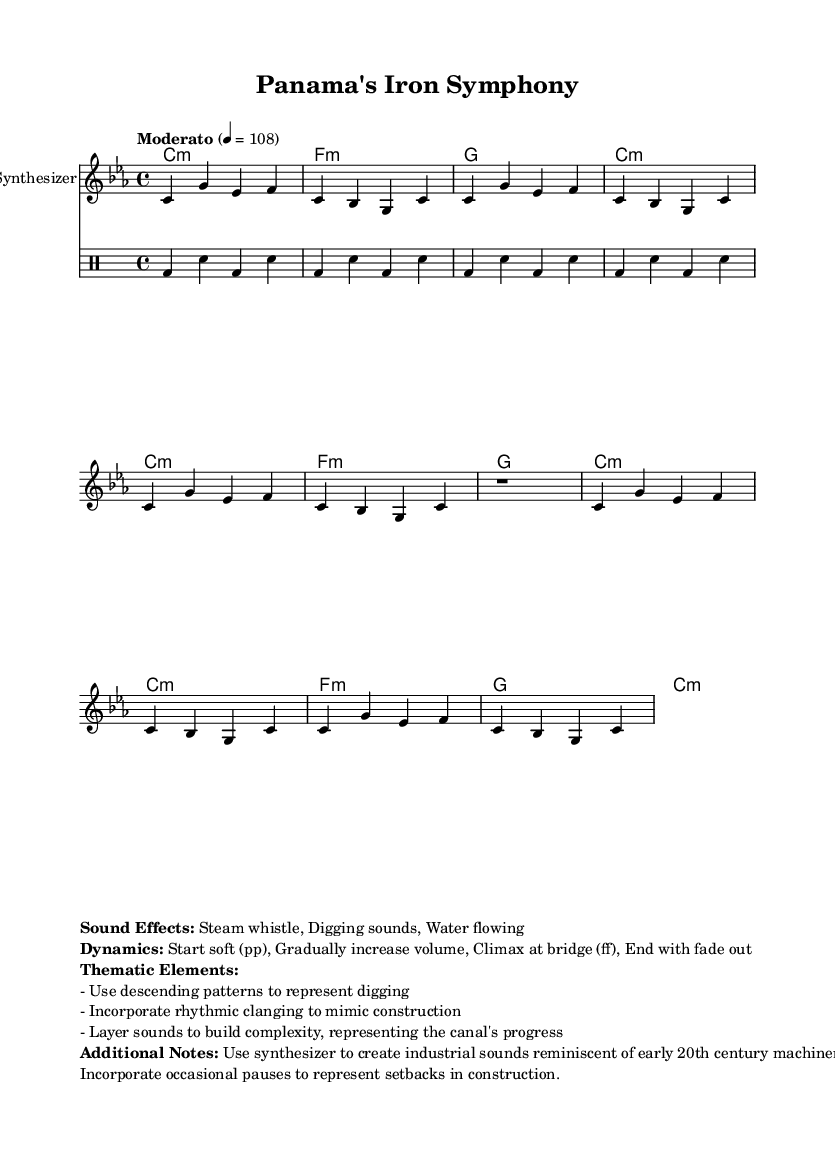What is the key signature of this music? The key signature is C minor, which has three flats (B, E, and A). This is identified from the global settings of the music sheet that states \key c \minor.
Answer: C minor What is the time signature of this piece? The time signature is 4/4, which means there are four beats per measure. This is indicated in the global settings with \time 4/4.
Answer: 4/4 What is the tempo marking of this piece? The tempo marking is "Moderato" at a quarter note equals 108 beats per minute, signifying a moderate pace. This is located in the global settings of the score.
Answer: Moderato 4 = 108 How many measures are repeated in the melody? The melody repeats the same pattern two times, as indicated by the \repeat unfold 2 in the melody section.
Answer: 2 What is the dynamic marking at the climax of the bridge? The dynamic marking at the climax of the bridge is "ff," which stands for fortissimo, indicating a very loud sound. This is specified in the additional notes section.
Answer: ff What thematic element is used to represent digging in this piece? The thematic element used to represent digging is descending patterns in the melody, which create a sensation of downward movement and effort. This is detailed in the markup section under thematic elements.
Answer: Descending patterns What sound effects are incorporated in the composition? The sound effects included are steam whistle, digging sounds, and water flowing, which are meant to create an immersive experience reflecting the construction theme. This is clearly noted in the sound effects section of the markup.
Answer: Steam whistle, Digging sounds, Water flowing 